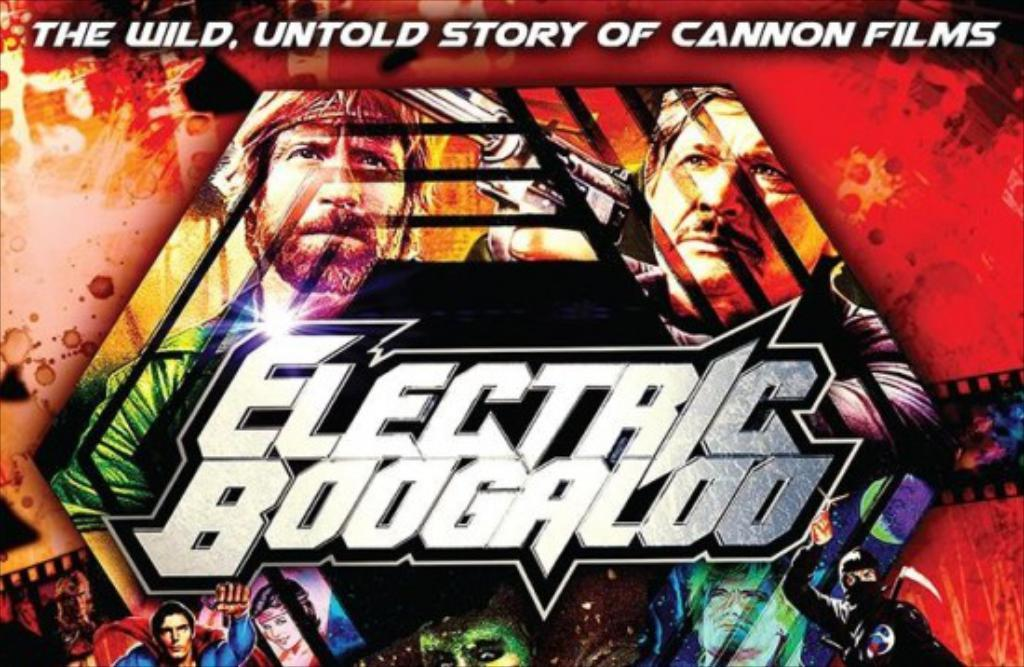What is present in the image that contains visual information? There is a poster in the image. What type of content is depicted on the poster? The poster contains images of persons. Is there any textual information on the poster? Yes, there is text written on the poster. What is the price of the play depicted on the waves in the image? There is no mention of a play or waves in the image, and therefore no price can be determined. 